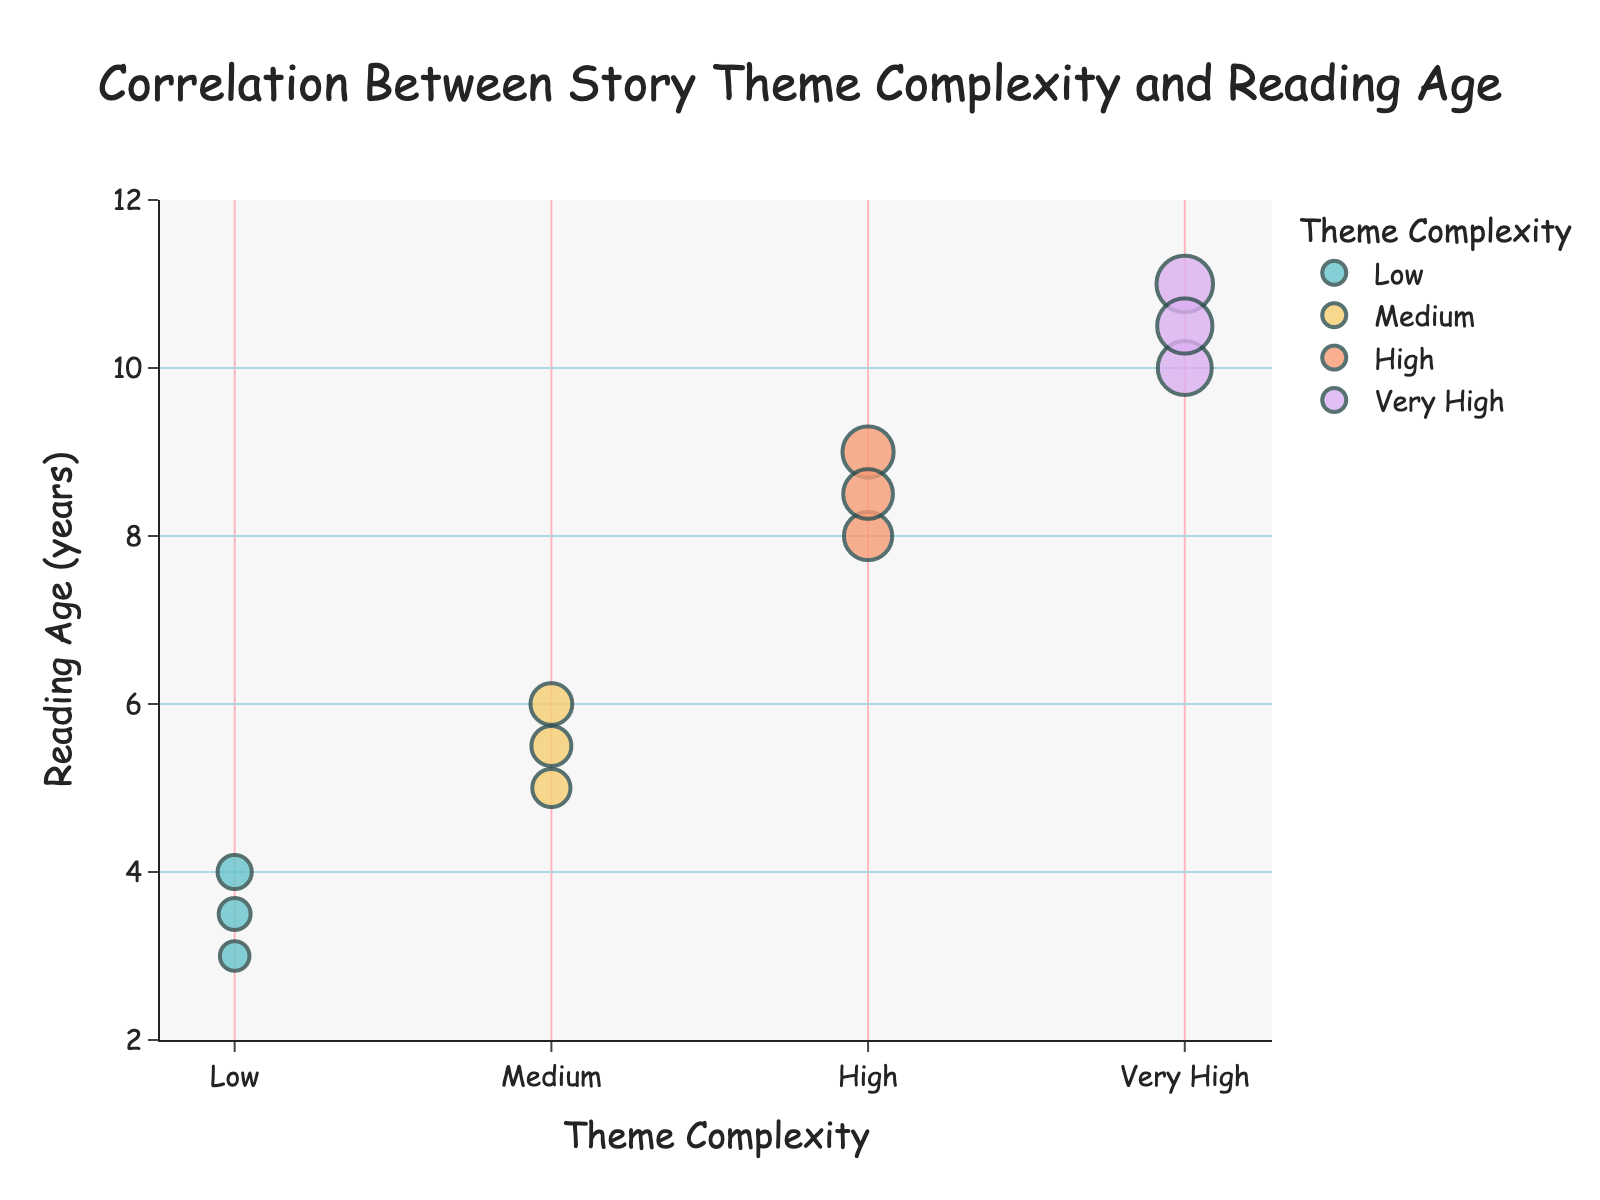What is the title of the scatter plot? The title of the scatter plot is displayed at the top of the figure. It summarizes the main insight the chart provides.
Answer: Correlation Between Story Theme Complexity and Reading Age How many different theme complexities are shown on the x-axis? To count the different theme complexities, look at the x-axis and note the distinct categories marked.
Answer: Four What is the range of the reading ages shown on the y-axis? The y-axis range is typically indicated by the lowest and highest tick marks shown on the axis.
Answer: 2 to 12 years Which theme complexity has the youngest average reading age? Calculate the average reading age for each theme complexity group. Sum the ages within each group and divide by the number of data points in that group. For example, Low has (3 + 4 + 3.5)/3 = 3.5.
Answer: Low What is the largest reading age difference within a single theme complexity? For each theme complexity, find the maximum and minimum reading ages, then calculate the difference. The largest reading difference will give the value.
Answer: Very High (difference of 1) Which theme complexity has the highest reading age? Compare the maximum reading ages for each theme complexity group to determine the highest value.
Answer: Very High What patterns can you see in the scatter plot between theme complexity and reading age? Look at how the data points are distributed. Notice the trend where higher theme complexities tend to correspond with higher reading ages.
Answer: Higher complexities correspond to higher reading ages Are there any outliers in the data? An outlier would be a data point that significantly deviates from the trend of the other points. Observe if any points seem to be isolated.
Answer: No significant outliers How are the markers colored, and what does this signify? Observe the different colors of the markers in the scatter plot. Each color represents one theme complexity group.
Answer: Each theme complexity group has a distinct color How does the reading age increase from 'Medium' to 'Very High' theme complexity? Track the reading ages associated with 'Medium' theme complexity and then compare them to those associated with 'Very High', noting the increase or trend between them.
Answer: Reading age increases from around 5-6 years to 10-11 years going from Medium to Very High 